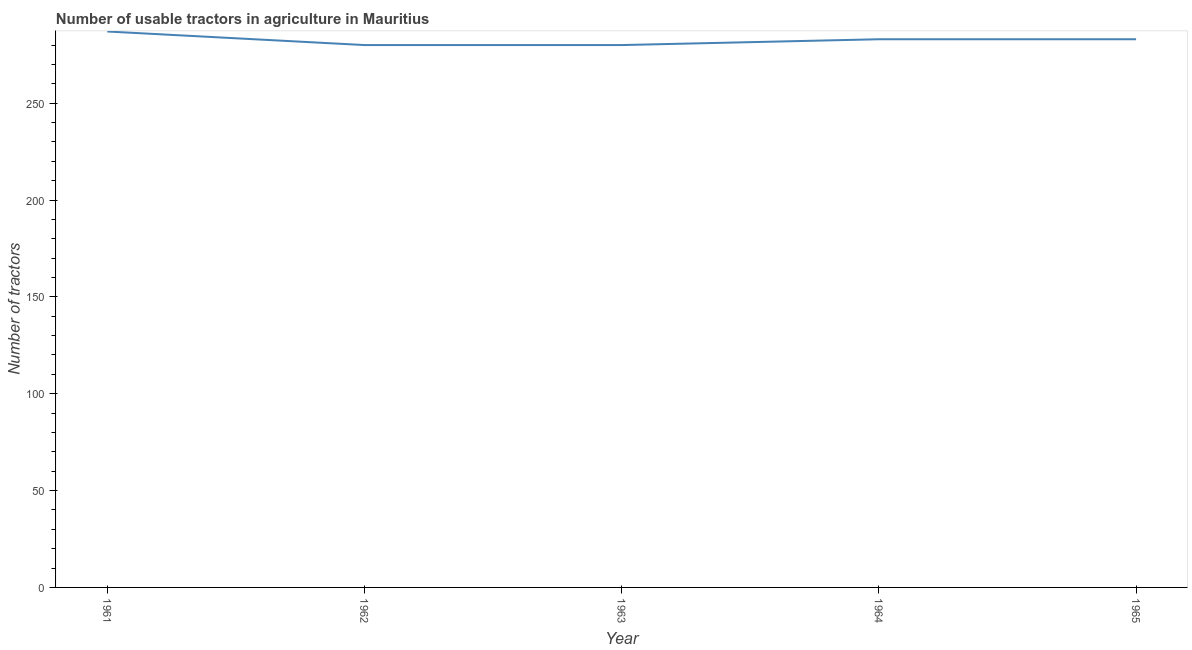What is the number of tractors in 1965?
Give a very brief answer. 283. Across all years, what is the maximum number of tractors?
Ensure brevity in your answer.  287. Across all years, what is the minimum number of tractors?
Offer a terse response. 280. In which year was the number of tractors maximum?
Offer a terse response. 1961. In which year was the number of tractors minimum?
Give a very brief answer. 1962. What is the sum of the number of tractors?
Keep it short and to the point. 1413. What is the difference between the number of tractors in 1961 and 1964?
Make the answer very short. 4. What is the average number of tractors per year?
Your response must be concise. 282.6. What is the median number of tractors?
Your response must be concise. 283. In how many years, is the number of tractors greater than 260 ?
Make the answer very short. 5. Do a majority of the years between 1963 and 1965 (inclusive) have number of tractors greater than 170 ?
Offer a very short reply. Yes. Is the number of tractors in 1962 less than that in 1963?
Provide a succinct answer. No. Is the difference between the number of tractors in 1962 and 1964 greater than the difference between any two years?
Offer a very short reply. No. What is the difference between the highest and the second highest number of tractors?
Offer a terse response. 4. Is the sum of the number of tractors in 1961 and 1964 greater than the maximum number of tractors across all years?
Provide a succinct answer. Yes. What is the difference between the highest and the lowest number of tractors?
Provide a short and direct response. 7. Does the number of tractors monotonically increase over the years?
Offer a very short reply. No. Does the graph contain grids?
Offer a terse response. No. What is the title of the graph?
Provide a short and direct response. Number of usable tractors in agriculture in Mauritius. What is the label or title of the Y-axis?
Keep it short and to the point. Number of tractors. What is the Number of tractors of 1961?
Ensure brevity in your answer.  287. What is the Number of tractors in 1962?
Your response must be concise. 280. What is the Number of tractors in 1963?
Provide a succinct answer. 280. What is the Number of tractors in 1964?
Provide a succinct answer. 283. What is the Number of tractors of 1965?
Your response must be concise. 283. What is the difference between the Number of tractors in 1961 and 1962?
Keep it short and to the point. 7. What is the difference between the Number of tractors in 1961 and 1963?
Provide a succinct answer. 7. What is the difference between the Number of tractors in 1962 and 1963?
Make the answer very short. 0. What is the difference between the Number of tractors in 1962 and 1965?
Your response must be concise. -3. What is the difference between the Number of tractors in 1963 and 1965?
Offer a terse response. -3. What is the difference between the Number of tractors in 1964 and 1965?
Provide a succinct answer. 0. What is the ratio of the Number of tractors in 1961 to that in 1965?
Your response must be concise. 1.01. What is the ratio of the Number of tractors in 1962 to that in 1963?
Ensure brevity in your answer.  1. What is the ratio of the Number of tractors in 1963 to that in 1964?
Provide a short and direct response. 0.99. What is the ratio of the Number of tractors in 1963 to that in 1965?
Your answer should be very brief. 0.99. What is the ratio of the Number of tractors in 1964 to that in 1965?
Provide a succinct answer. 1. 